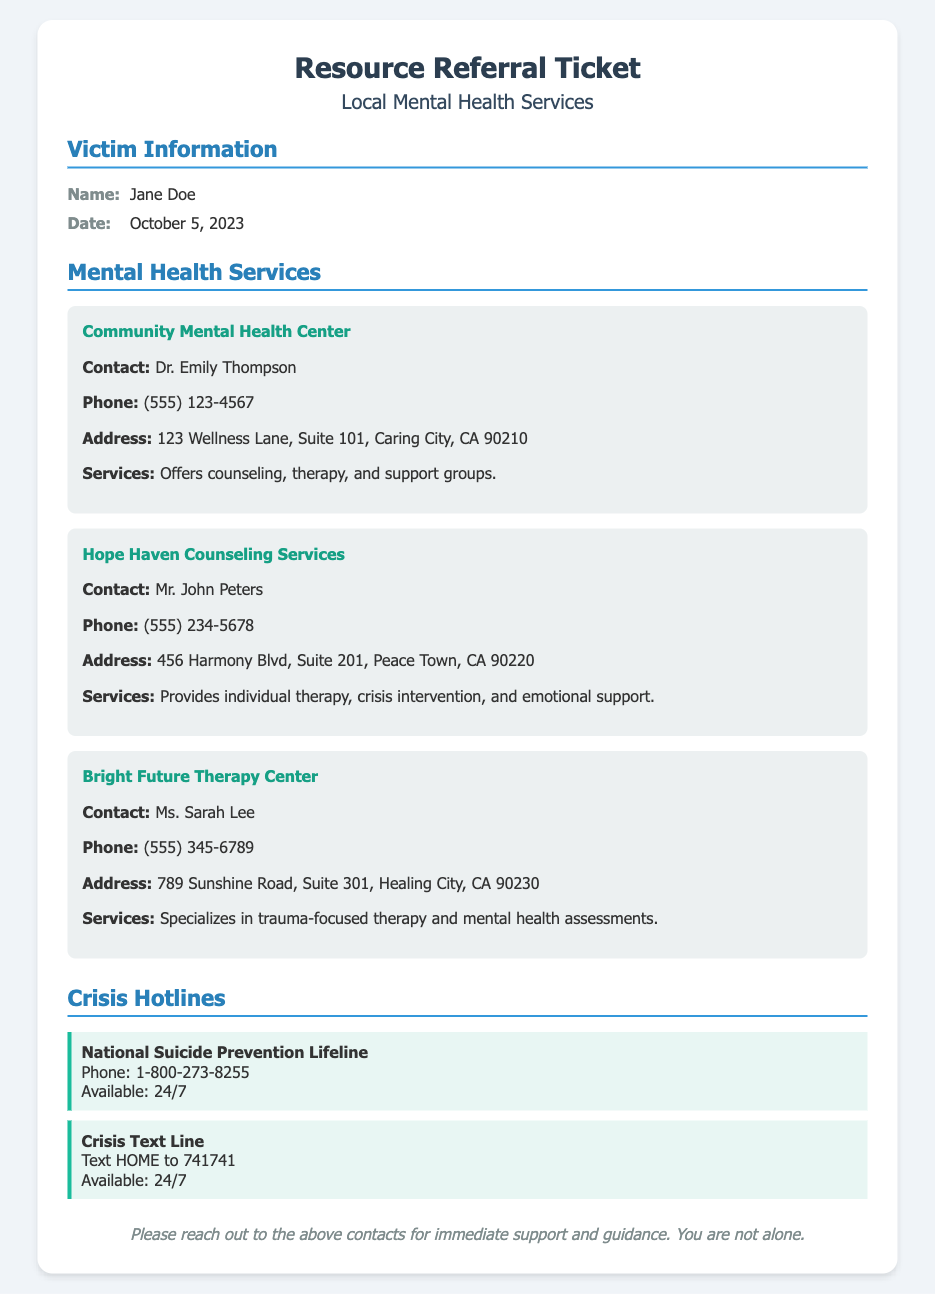What is the name of the victim? The document states the victim's name in the Victim Information section.
Answer: Jane Doe What is the date of the ticket? The date can be found right next to the name in the Victim Information section.
Answer: October 5, 2023 What is the phone number for the Community Mental Health Center? The phone number for this service is provided within the Mental Health Services section.
Answer: (555) 123-4567 Who is the contact person for Hope Haven Counseling Services? The contact person is mentioned in the service details for Hope Haven Counseling Services.
Answer: Mr. John Peters What type of therapy does Bright Future Therapy Center specialize in? This information is available in the description of services offered by Bright Future Therapy Center.
Answer: Trauma-focused therapy How many crisis hotlines are listed in the document? The number of crisis hotlines can be counted from the Crisis Hotlines section.
Answer: Two What service does the National Suicide Prevention Lifeline provide? This is inferred from the name and description of the hotline in the document.
Answer: Suicide prevention What is the address of the Bright Future Therapy Center? The address is included in the service details for the Bright Future Therapy Center.
Answer: 789 Sunshine Road, Suite 301, Healing City, CA 90230 